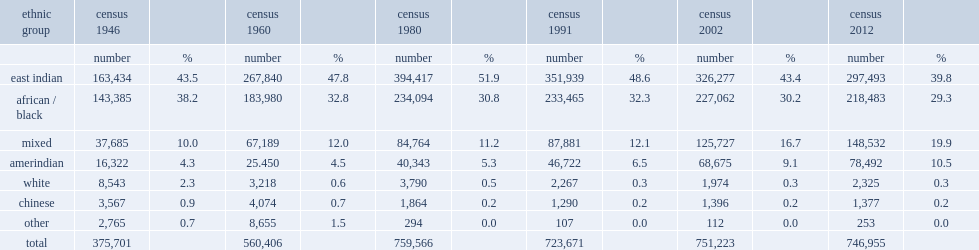Can you give me this table as a dict? {'header': ['ethnic group', 'census 1946', '', 'census 1960', '', 'census 1980', '', 'census 1991', '', 'census 2002', '', 'census 2012', ''], 'rows': [['', 'number', '%', 'number', '%', 'number', '%', 'number', '%', 'number', '%', 'number', '%'], ['east indian', '163,434', '43.5', '267,840', '47.8', '394,417', '51.9', '351,939', '48.6', '326,277', '43.4', '297,493', '39.8'], ['african / black', '143,385', '38.2', '183,980', '32.8', '234,094', '30.8', '233,465', '32.3', '227,062', '30.2', '218,483', '29.3'], ['mixed', '37,685', '10.0', '67,189', '12.0', '84,764', '11.2', '87,881', '12.1', '125,727', '16.7', '148,532', '19.9'], ['amerindian', '16,322', '4.3', '25.450', '4.5', '40,343', '5.3', '46,722', '6.5', '68,675', '9.1', '78,492', '10.5'], ['white', '8,543', '2.3', '3,218', '0.6', '3,790', '0.5', '2,267', '0.3', '1,974', '0.3', '2,325', '0.3'], ['chinese', '3,567', '0.9', '4,074', '0.7', '1,864', '0.2', '1,290', '0.2', '1,396', '0.2', '1,377', '0.2'], ['other', '2,765', '0.7', '8,655', '1.5', '294', '0.0', '107', '0.0', '112', '0.0', '253', '0.0'], ['total', '375,701', '', '560,406', '', '759,566', '', '723,671', '', '751,223', '', '746,955', '']]} In 2002, what percent of guyana is african descent? 30.2. What percent of the population was guyanese in 1980. 51.9. 